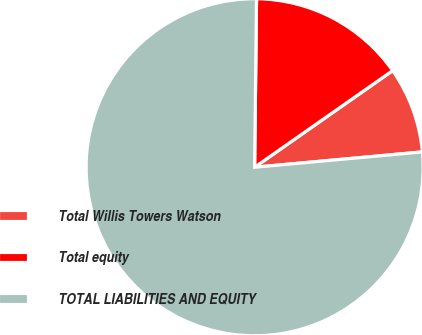Convert chart. <chart><loc_0><loc_0><loc_500><loc_500><pie_chart><fcel>Total Willis Towers Watson<fcel>Total equity<fcel>TOTAL LIABILITIES AND EQUITY<nl><fcel>8.27%<fcel>15.1%<fcel>76.63%<nl></chart> 